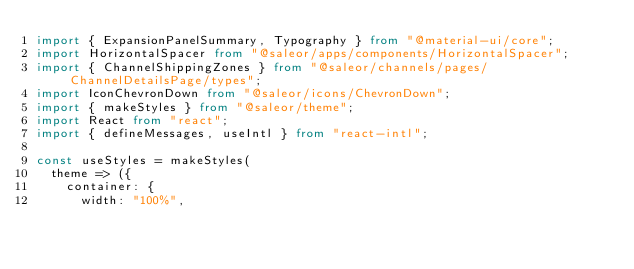Convert code to text. <code><loc_0><loc_0><loc_500><loc_500><_TypeScript_>import { ExpansionPanelSummary, Typography } from "@material-ui/core";
import HorizontalSpacer from "@saleor/apps/components/HorizontalSpacer";
import { ChannelShippingZones } from "@saleor/channels/pages/ChannelDetailsPage/types";
import IconChevronDown from "@saleor/icons/ChevronDown";
import { makeStyles } from "@saleor/theme";
import React from "react";
import { defineMessages, useIntl } from "react-intl";

const useStyles = makeStyles(
  theme => ({
    container: {
      width: "100%",</code> 